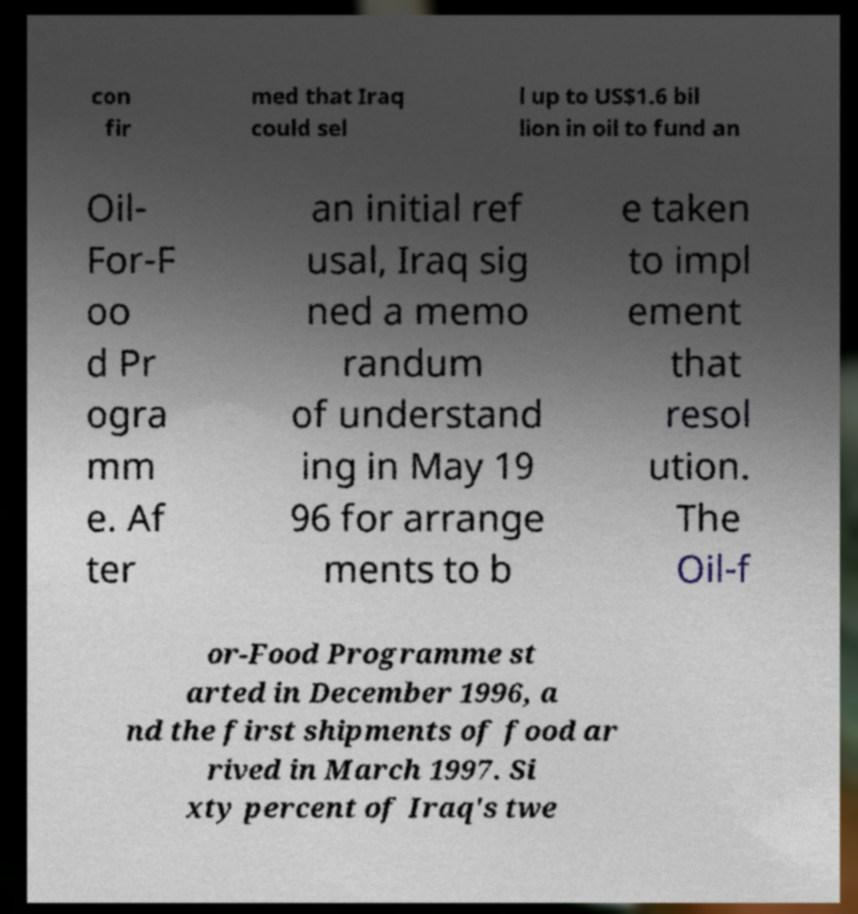There's text embedded in this image that I need extracted. Can you transcribe it verbatim? con fir med that Iraq could sel l up to US$1.6 bil lion in oil to fund an Oil- For-F oo d Pr ogra mm e. Af ter an initial ref usal, Iraq sig ned a memo randum of understand ing in May 19 96 for arrange ments to b e taken to impl ement that resol ution. The Oil-f or-Food Programme st arted in December 1996, a nd the first shipments of food ar rived in March 1997. Si xty percent of Iraq's twe 